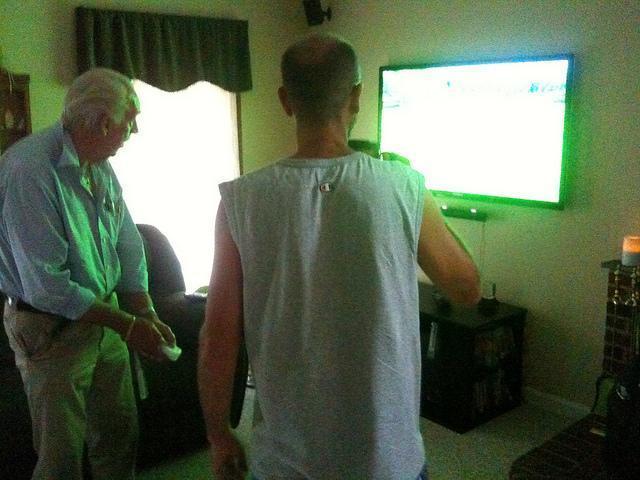How many people are in the picture?
Give a very brief answer. 2. How many zebras are babies?
Give a very brief answer. 0. 